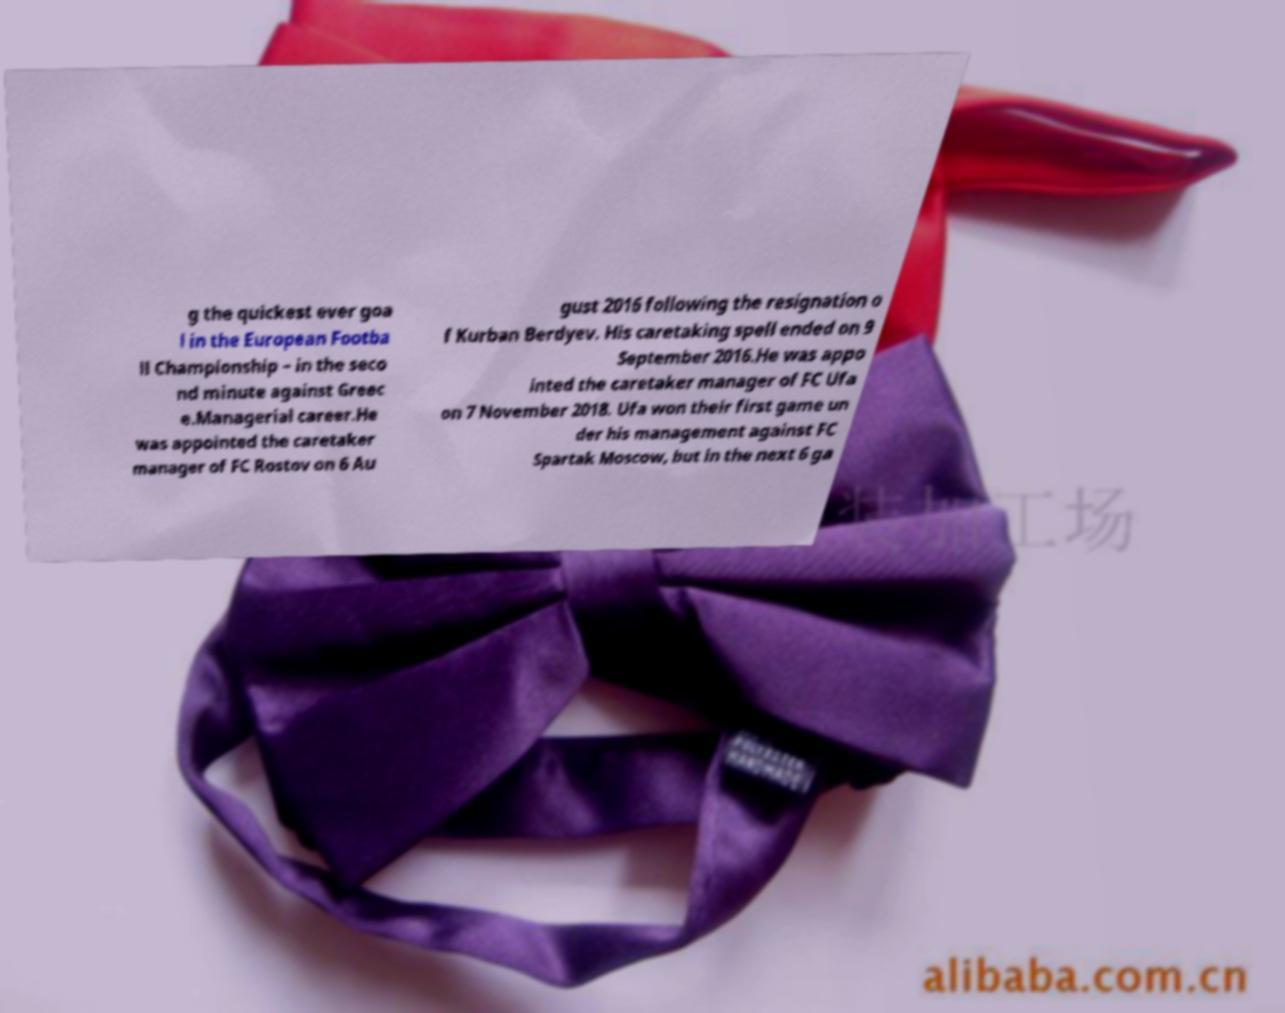I need the written content from this picture converted into text. Can you do that? g the quickest ever goa l in the European Footba ll Championship – in the seco nd minute against Greec e.Managerial career.He was appointed the caretaker manager of FC Rostov on 6 Au gust 2016 following the resignation o f Kurban Berdyev. His caretaking spell ended on 9 September 2016.He was appo inted the caretaker manager of FC Ufa on 7 November 2018. Ufa won their first game un der his management against FC Spartak Moscow, but in the next 6 ga 